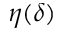<formula> <loc_0><loc_0><loc_500><loc_500>\eta ( \delta )</formula> 